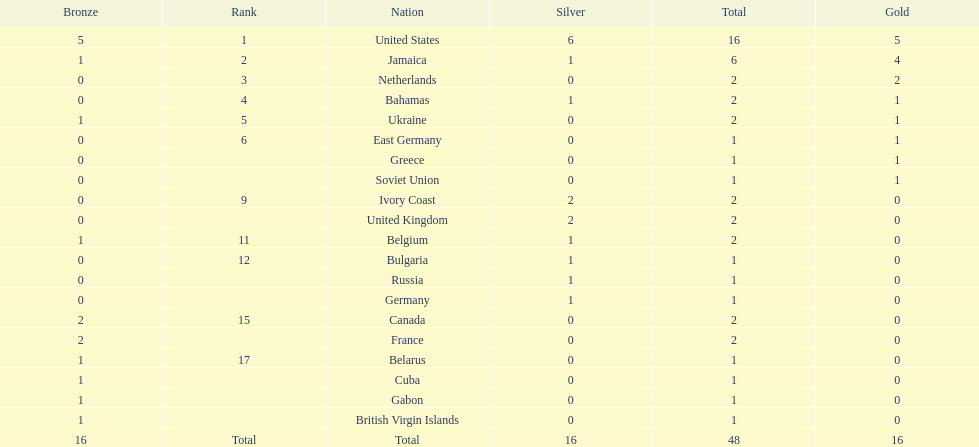What is the total number of gold medals won by both the us and jamaica? 9. Would you be able to parse every entry in this table? {'header': ['Bronze', 'Rank', 'Nation', 'Silver', 'Total', 'Gold'], 'rows': [['5', '1', 'United States', '6', '16', '5'], ['1', '2', 'Jamaica', '1', '6', '4'], ['0', '3', 'Netherlands', '0', '2', '2'], ['0', '4', 'Bahamas', '1', '2', '1'], ['1', '5', 'Ukraine', '0', '2', '1'], ['0', '6', 'East Germany', '0', '1', '1'], ['0', '', 'Greece', '0', '1', '1'], ['0', '', 'Soviet Union', '0', '1', '1'], ['0', '9', 'Ivory Coast', '2', '2', '0'], ['0', '', 'United Kingdom', '2', '2', '0'], ['1', '11', 'Belgium', '1', '2', '0'], ['0', '12', 'Bulgaria', '1', '1', '0'], ['0', '', 'Russia', '1', '1', '0'], ['0', '', 'Germany', '1', '1', '0'], ['2', '15', 'Canada', '0', '2', '0'], ['2', '', 'France', '0', '2', '0'], ['1', '17', 'Belarus', '0', '1', '0'], ['1', '', 'Cuba', '0', '1', '0'], ['1', '', 'Gabon', '0', '1', '0'], ['1', '', 'British Virgin Islands', '0', '1', '0'], ['16', 'Total', 'Total', '16', '48', '16']]} 